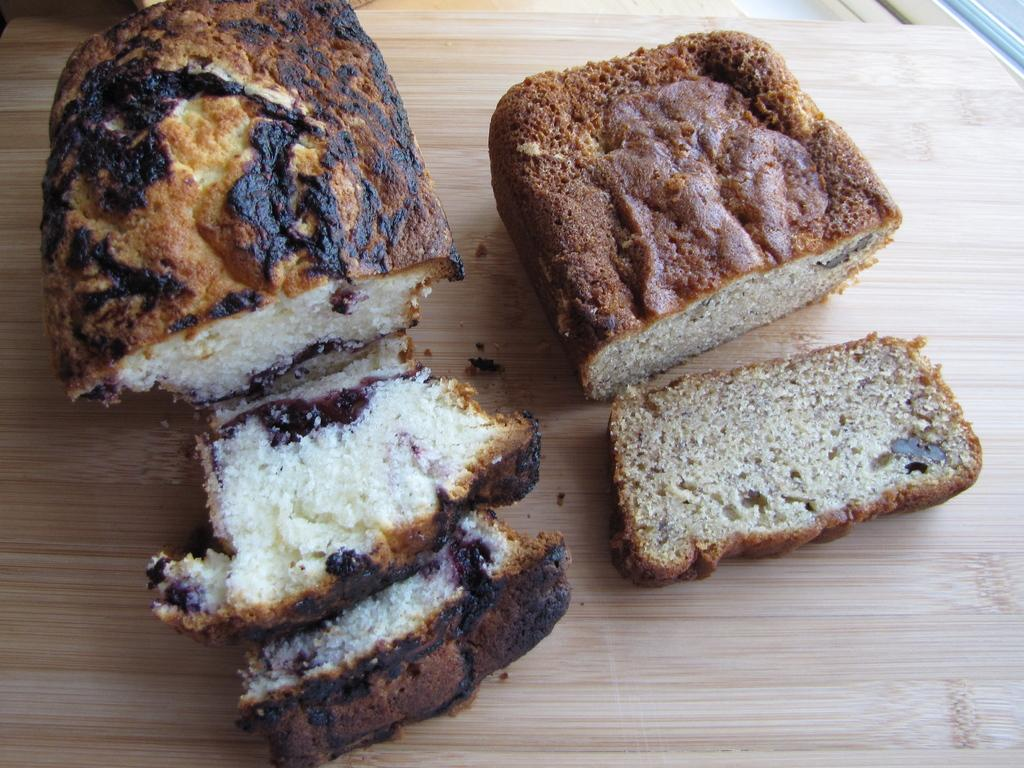What is present on the table in the image? There is food on the table in the image. What type of fang can be seen in the image? There is no fang present in the image; it features food on a table. What political position does the minister hold in the image? There is no minister or political position mentioned in the image; it only shows food on a table. 